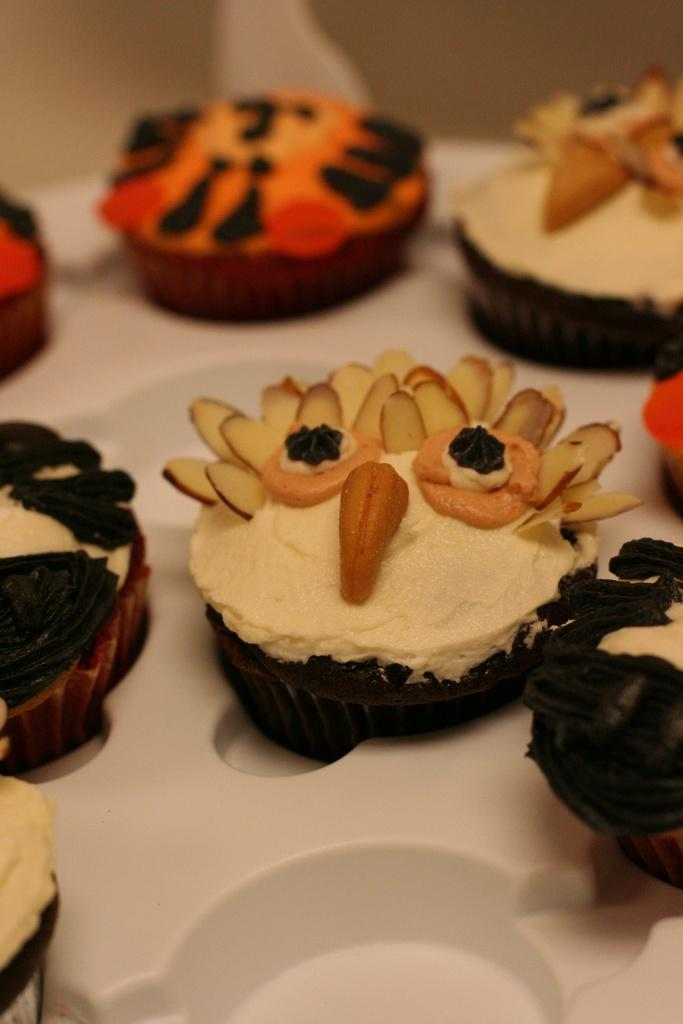What type of food can be seen in the image? There are cupcakes in the image. How are the cupcakes arranged? The cupcakes are arranged on a tray. What type of dinosaur can be seen in the image? There are no dinosaurs present in the image; it features cupcakes arranged on a tray. What knowledge can be gained from the image? The image provides information about the arrangement of cupcakes on a tray, but it does not convey any specific knowledge beyond that. 